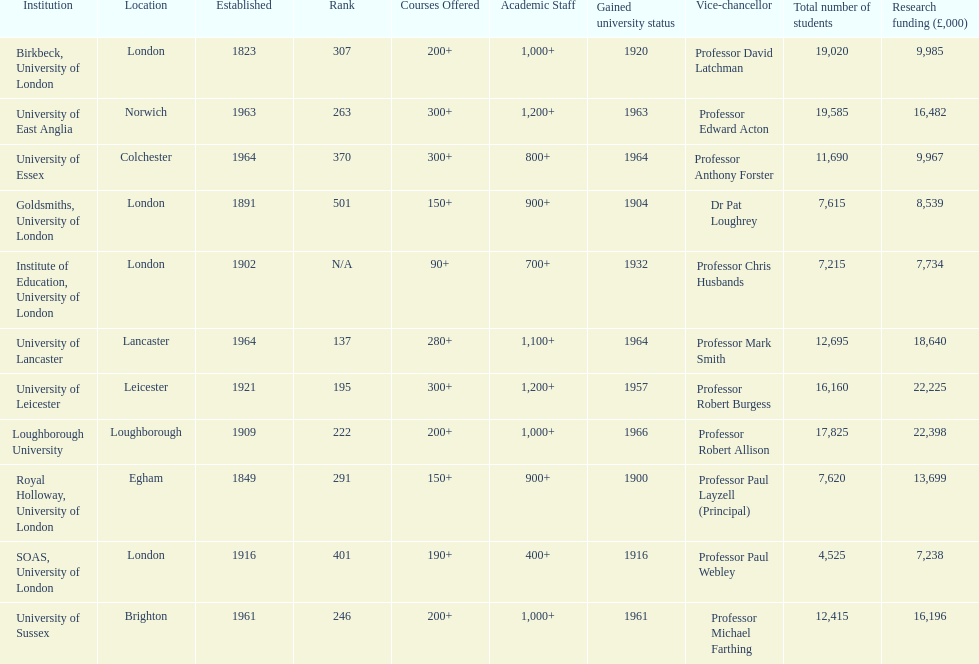How many of the institutions are located in london? 4. 